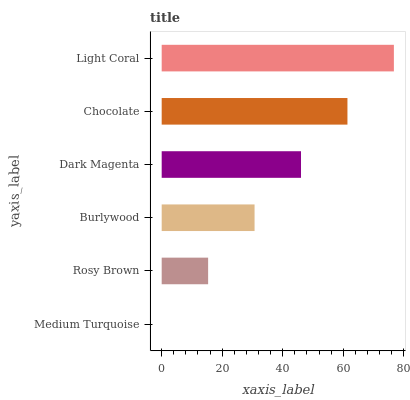Is Medium Turquoise the minimum?
Answer yes or no. Yes. Is Light Coral the maximum?
Answer yes or no. Yes. Is Rosy Brown the minimum?
Answer yes or no. No. Is Rosy Brown the maximum?
Answer yes or no. No. Is Rosy Brown greater than Medium Turquoise?
Answer yes or no. Yes. Is Medium Turquoise less than Rosy Brown?
Answer yes or no. Yes. Is Medium Turquoise greater than Rosy Brown?
Answer yes or no. No. Is Rosy Brown less than Medium Turquoise?
Answer yes or no. No. Is Dark Magenta the high median?
Answer yes or no. Yes. Is Burlywood the low median?
Answer yes or no. Yes. Is Burlywood the high median?
Answer yes or no. No. Is Dark Magenta the low median?
Answer yes or no. No. 